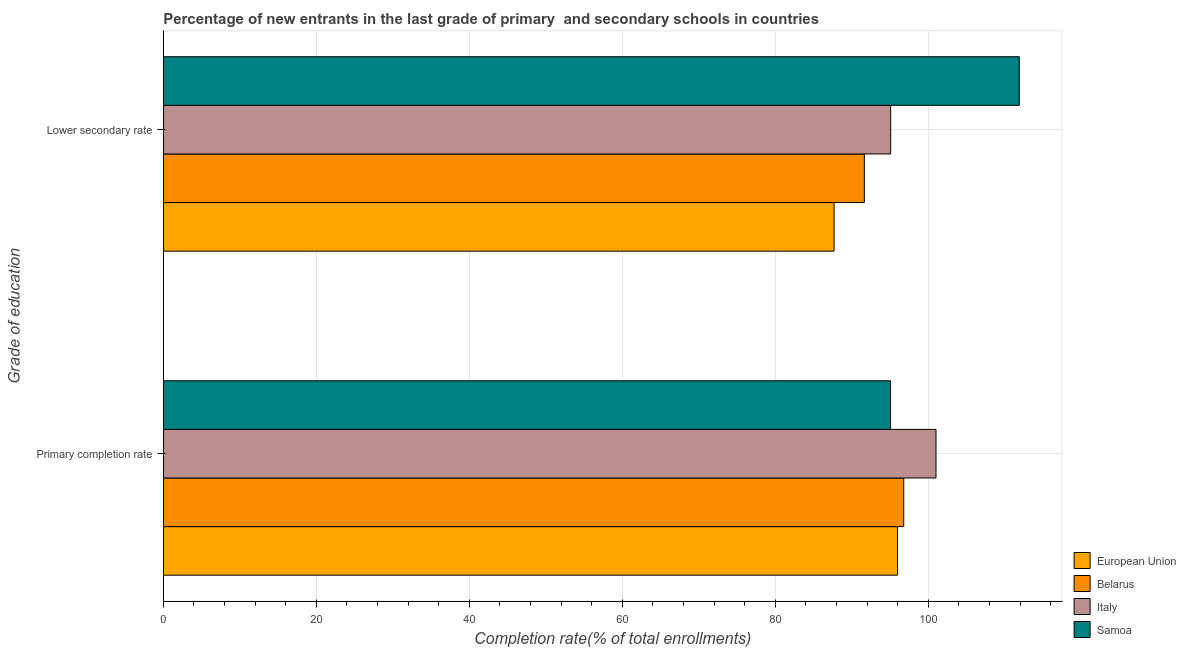How many groups of bars are there?
Offer a very short reply. 2. Are the number of bars per tick equal to the number of legend labels?
Keep it short and to the point. Yes. How many bars are there on the 2nd tick from the bottom?
Make the answer very short. 4. What is the label of the 2nd group of bars from the top?
Your answer should be compact. Primary completion rate. What is the completion rate in secondary schools in Italy?
Provide a short and direct response. 95.08. Across all countries, what is the maximum completion rate in secondary schools?
Your answer should be very brief. 111.89. Across all countries, what is the minimum completion rate in secondary schools?
Ensure brevity in your answer.  87.68. In which country was the completion rate in primary schools maximum?
Your response must be concise. Italy. In which country was the completion rate in primary schools minimum?
Offer a terse response. Samoa. What is the total completion rate in secondary schools in the graph?
Your answer should be compact. 386.29. What is the difference between the completion rate in primary schools in Italy and that in Belarus?
Your answer should be very brief. 4.22. What is the difference between the completion rate in primary schools in Italy and the completion rate in secondary schools in Belarus?
Give a very brief answer. 9.37. What is the average completion rate in primary schools per country?
Your response must be concise. 97.21. What is the difference between the completion rate in primary schools and completion rate in secondary schools in European Union?
Ensure brevity in your answer.  8.29. In how many countries, is the completion rate in secondary schools greater than 92 %?
Your answer should be very brief. 2. What is the ratio of the completion rate in primary schools in Italy to that in European Union?
Give a very brief answer. 1.05. In how many countries, is the completion rate in primary schools greater than the average completion rate in primary schools taken over all countries?
Your answer should be very brief. 1. What does the 2nd bar from the top in Primary completion rate represents?
Make the answer very short. Italy. Are all the bars in the graph horizontal?
Your answer should be compact. Yes. How many countries are there in the graph?
Keep it short and to the point. 4. What is the difference between two consecutive major ticks on the X-axis?
Your response must be concise. 20. What is the title of the graph?
Give a very brief answer. Percentage of new entrants in the last grade of primary  and secondary schools in countries. Does "Sri Lanka" appear as one of the legend labels in the graph?
Give a very brief answer. No. What is the label or title of the X-axis?
Your answer should be very brief. Completion rate(% of total enrollments). What is the label or title of the Y-axis?
Provide a succinct answer. Grade of education. What is the Completion rate(% of total enrollments) of European Union in Primary completion rate?
Ensure brevity in your answer.  95.98. What is the Completion rate(% of total enrollments) of Belarus in Primary completion rate?
Provide a succinct answer. 96.79. What is the Completion rate(% of total enrollments) in Italy in Primary completion rate?
Keep it short and to the point. 101. What is the Completion rate(% of total enrollments) of Samoa in Primary completion rate?
Provide a short and direct response. 95.06. What is the Completion rate(% of total enrollments) of European Union in Lower secondary rate?
Provide a succinct answer. 87.68. What is the Completion rate(% of total enrollments) of Belarus in Lower secondary rate?
Provide a succinct answer. 91.64. What is the Completion rate(% of total enrollments) of Italy in Lower secondary rate?
Offer a terse response. 95.08. What is the Completion rate(% of total enrollments) of Samoa in Lower secondary rate?
Provide a short and direct response. 111.89. Across all Grade of education, what is the maximum Completion rate(% of total enrollments) in European Union?
Provide a short and direct response. 95.98. Across all Grade of education, what is the maximum Completion rate(% of total enrollments) in Belarus?
Your answer should be compact. 96.79. Across all Grade of education, what is the maximum Completion rate(% of total enrollments) of Italy?
Your answer should be compact. 101. Across all Grade of education, what is the maximum Completion rate(% of total enrollments) in Samoa?
Provide a succinct answer. 111.89. Across all Grade of education, what is the minimum Completion rate(% of total enrollments) of European Union?
Your answer should be very brief. 87.68. Across all Grade of education, what is the minimum Completion rate(% of total enrollments) in Belarus?
Offer a terse response. 91.64. Across all Grade of education, what is the minimum Completion rate(% of total enrollments) in Italy?
Your response must be concise. 95.08. Across all Grade of education, what is the minimum Completion rate(% of total enrollments) of Samoa?
Offer a terse response. 95.06. What is the total Completion rate(% of total enrollments) of European Union in the graph?
Keep it short and to the point. 183.66. What is the total Completion rate(% of total enrollments) in Belarus in the graph?
Provide a short and direct response. 188.42. What is the total Completion rate(% of total enrollments) of Italy in the graph?
Keep it short and to the point. 196.08. What is the total Completion rate(% of total enrollments) in Samoa in the graph?
Provide a short and direct response. 206.96. What is the difference between the Completion rate(% of total enrollments) in European Union in Primary completion rate and that in Lower secondary rate?
Offer a very short reply. 8.29. What is the difference between the Completion rate(% of total enrollments) in Belarus in Primary completion rate and that in Lower secondary rate?
Provide a short and direct response. 5.15. What is the difference between the Completion rate(% of total enrollments) of Italy in Primary completion rate and that in Lower secondary rate?
Your answer should be compact. 5.92. What is the difference between the Completion rate(% of total enrollments) of Samoa in Primary completion rate and that in Lower secondary rate?
Your answer should be very brief. -16.83. What is the difference between the Completion rate(% of total enrollments) of European Union in Primary completion rate and the Completion rate(% of total enrollments) of Belarus in Lower secondary rate?
Your answer should be compact. 4.34. What is the difference between the Completion rate(% of total enrollments) in European Union in Primary completion rate and the Completion rate(% of total enrollments) in Italy in Lower secondary rate?
Provide a short and direct response. 0.9. What is the difference between the Completion rate(% of total enrollments) of European Union in Primary completion rate and the Completion rate(% of total enrollments) of Samoa in Lower secondary rate?
Provide a succinct answer. -15.92. What is the difference between the Completion rate(% of total enrollments) of Belarus in Primary completion rate and the Completion rate(% of total enrollments) of Italy in Lower secondary rate?
Offer a terse response. 1.71. What is the difference between the Completion rate(% of total enrollments) of Belarus in Primary completion rate and the Completion rate(% of total enrollments) of Samoa in Lower secondary rate?
Your response must be concise. -15.11. What is the difference between the Completion rate(% of total enrollments) in Italy in Primary completion rate and the Completion rate(% of total enrollments) in Samoa in Lower secondary rate?
Give a very brief answer. -10.89. What is the average Completion rate(% of total enrollments) of European Union per Grade of education?
Give a very brief answer. 91.83. What is the average Completion rate(% of total enrollments) of Belarus per Grade of education?
Give a very brief answer. 94.21. What is the average Completion rate(% of total enrollments) in Italy per Grade of education?
Provide a short and direct response. 98.04. What is the average Completion rate(% of total enrollments) in Samoa per Grade of education?
Ensure brevity in your answer.  103.48. What is the difference between the Completion rate(% of total enrollments) of European Union and Completion rate(% of total enrollments) of Belarus in Primary completion rate?
Your answer should be compact. -0.81. What is the difference between the Completion rate(% of total enrollments) in European Union and Completion rate(% of total enrollments) in Italy in Primary completion rate?
Your answer should be compact. -5.03. What is the difference between the Completion rate(% of total enrollments) of European Union and Completion rate(% of total enrollments) of Samoa in Primary completion rate?
Provide a succinct answer. 0.91. What is the difference between the Completion rate(% of total enrollments) of Belarus and Completion rate(% of total enrollments) of Italy in Primary completion rate?
Keep it short and to the point. -4.22. What is the difference between the Completion rate(% of total enrollments) of Belarus and Completion rate(% of total enrollments) of Samoa in Primary completion rate?
Provide a short and direct response. 1.72. What is the difference between the Completion rate(% of total enrollments) of Italy and Completion rate(% of total enrollments) of Samoa in Primary completion rate?
Provide a short and direct response. 5.94. What is the difference between the Completion rate(% of total enrollments) in European Union and Completion rate(% of total enrollments) in Belarus in Lower secondary rate?
Provide a succinct answer. -3.95. What is the difference between the Completion rate(% of total enrollments) in European Union and Completion rate(% of total enrollments) in Italy in Lower secondary rate?
Ensure brevity in your answer.  -7.4. What is the difference between the Completion rate(% of total enrollments) in European Union and Completion rate(% of total enrollments) in Samoa in Lower secondary rate?
Provide a short and direct response. -24.21. What is the difference between the Completion rate(% of total enrollments) of Belarus and Completion rate(% of total enrollments) of Italy in Lower secondary rate?
Ensure brevity in your answer.  -3.45. What is the difference between the Completion rate(% of total enrollments) in Belarus and Completion rate(% of total enrollments) in Samoa in Lower secondary rate?
Your response must be concise. -20.26. What is the difference between the Completion rate(% of total enrollments) in Italy and Completion rate(% of total enrollments) in Samoa in Lower secondary rate?
Provide a short and direct response. -16.81. What is the ratio of the Completion rate(% of total enrollments) in European Union in Primary completion rate to that in Lower secondary rate?
Keep it short and to the point. 1.09. What is the ratio of the Completion rate(% of total enrollments) in Belarus in Primary completion rate to that in Lower secondary rate?
Provide a short and direct response. 1.06. What is the ratio of the Completion rate(% of total enrollments) in Italy in Primary completion rate to that in Lower secondary rate?
Offer a terse response. 1.06. What is the ratio of the Completion rate(% of total enrollments) in Samoa in Primary completion rate to that in Lower secondary rate?
Your response must be concise. 0.85. What is the difference between the highest and the second highest Completion rate(% of total enrollments) of European Union?
Your answer should be compact. 8.29. What is the difference between the highest and the second highest Completion rate(% of total enrollments) of Belarus?
Give a very brief answer. 5.15. What is the difference between the highest and the second highest Completion rate(% of total enrollments) of Italy?
Your answer should be compact. 5.92. What is the difference between the highest and the second highest Completion rate(% of total enrollments) of Samoa?
Ensure brevity in your answer.  16.83. What is the difference between the highest and the lowest Completion rate(% of total enrollments) in European Union?
Keep it short and to the point. 8.29. What is the difference between the highest and the lowest Completion rate(% of total enrollments) of Belarus?
Provide a short and direct response. 5.15. What is the difference between the highest and the lowest Completion rate(% of total enrollments) in Italy?
Your answer should be compact. 5.92. What is the difference between the highest and the lowest Completion rate(% of total enrollments) in Samoa?
Offer a terse response. 16.83. 